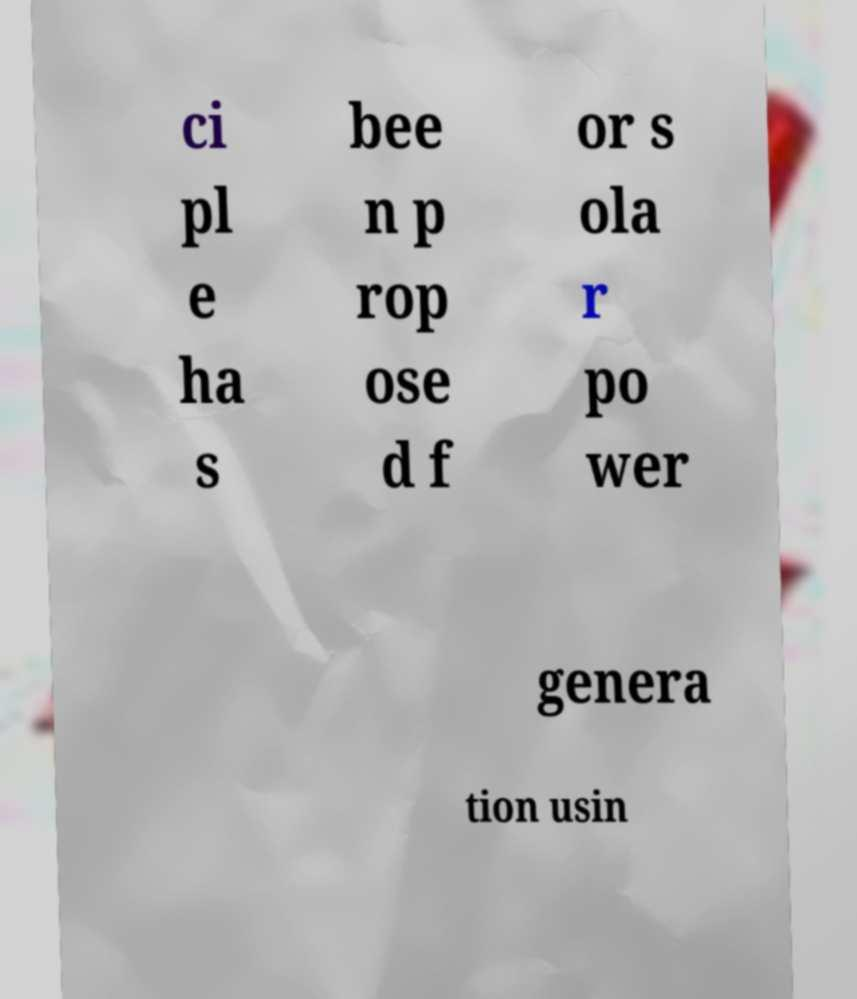Please read and relay the text visible in this image. What does it say? ci pl e ha s bee n p rop ose d f or s ola r po wer genera tion usin 